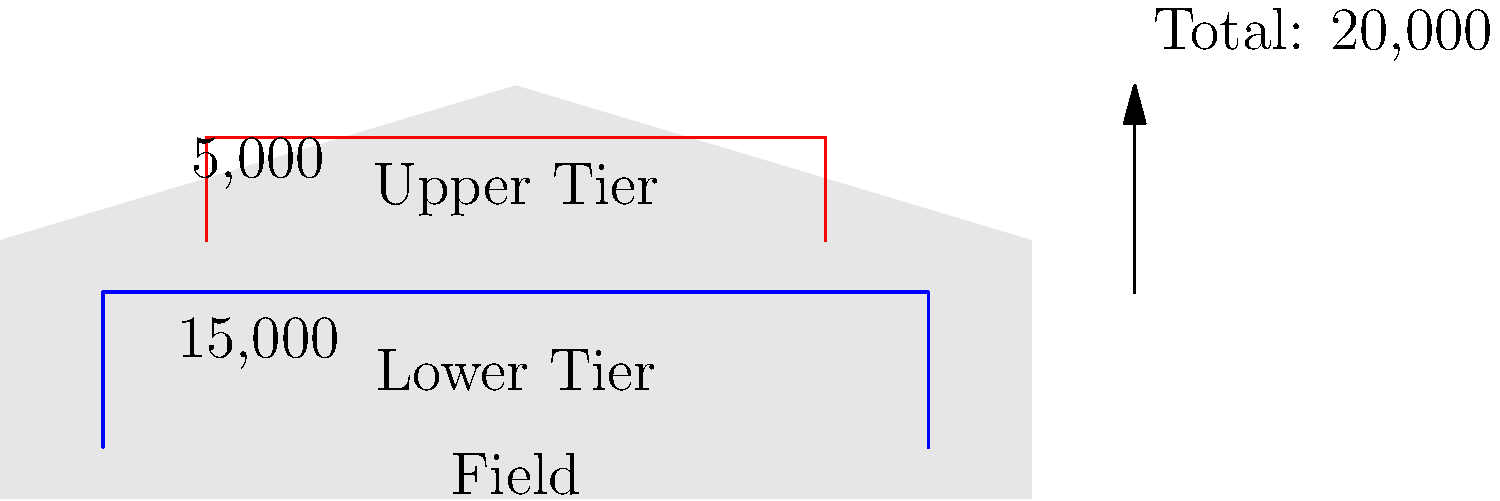Based on the stadium cross-section diagram of Estadio Mazatlán, what is the total seating capacity, and how is it distributed between the lower and upper tiers? To determine the total seating capacity and its distribution, let's analyze the diagram step-by-step:

1. Lower Tier:
   - The blue section represents the lower tier.
   - The capacity for the lower tier is clearly labeled as 15,000.

2. Upper Tier:
   - The red section represents the upper tier.
   - The capacity for the upper tier is labeled as 5,000.

3. Total Capacity:
   - To calculate the total capacity, we add the lower and upper tier capacities:
     $$ \text{Total Capacity} = \text{Lower Tier} + \text{Upper Tier} $$
     $$ \text{Total Capacity} = 15,000 + 5,000 = 20,000 $$
   - This calculation is confirmed by the "Total: 20,000" label with an arrow on the right side of the diagram.

4. Distribution:
   - Lower Tier: 15,000 seats (75% of total capacity)
   - Upper Tier: 5,000 seats (25% of total capacity)

Therefore, the total seating capacity of Estadio Mazatlán is 20,000, with 15,000 seats in the lower tier and 5,000 seats in the upper tier.
Answer: 20,000 total; 15,000 lower tier, 5,000 upper tier 